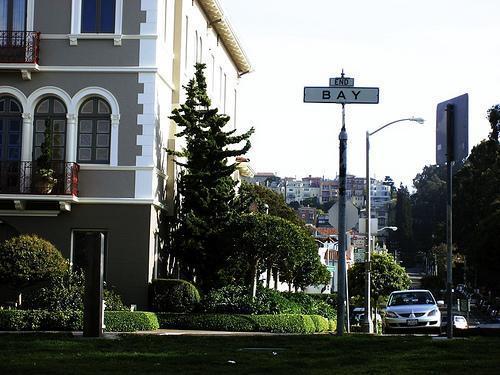How many motorcycles are parked in front of the home?
Give a very brief answer. 0. How many people are in the street?
Give a very brief answer. 0. How many clocks can be seen in the photo?
Give a very brief answer. 0. How many cars are visible on this street?
Give a very brief answer. 1. 